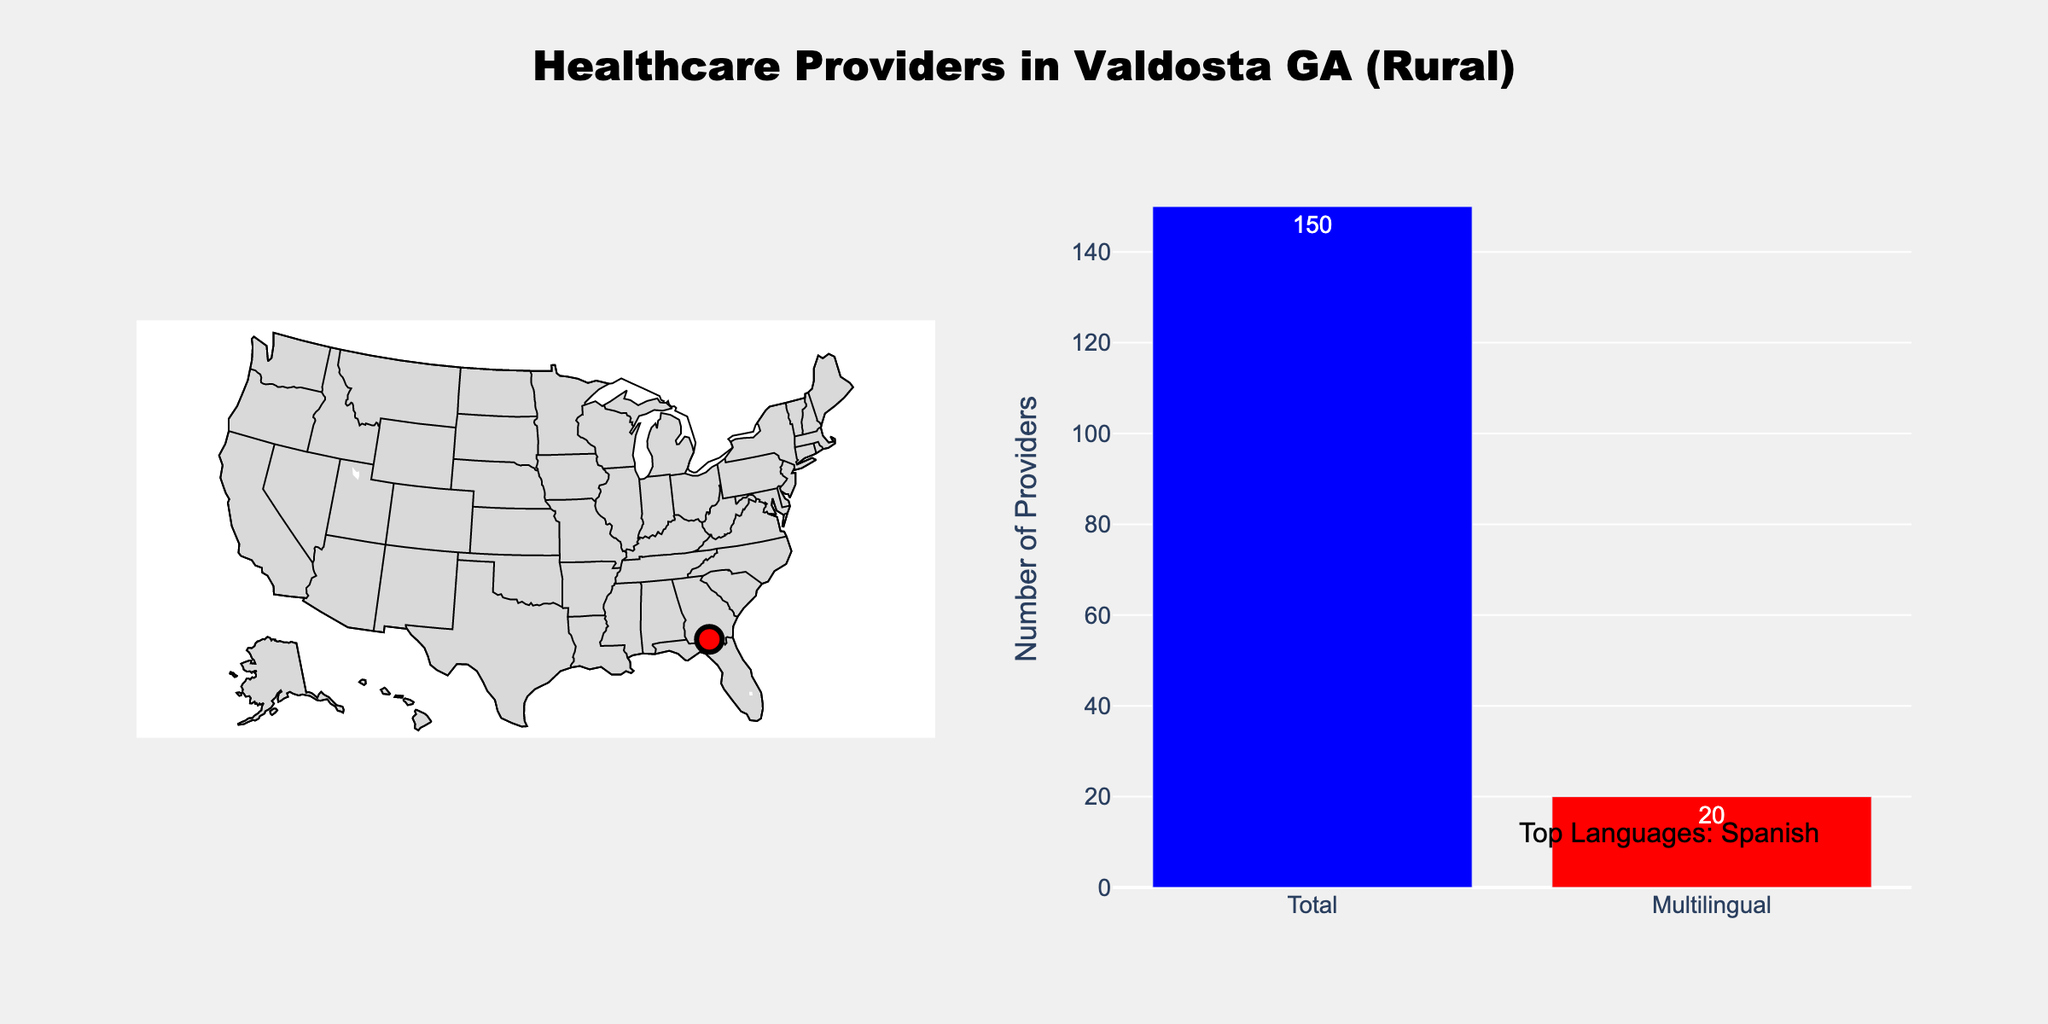What is the title of the figure? The title is displayed at the top center of the figure and reads "Healthcare Providers in Valdosta GA (Rural)".
Answer: Healthcare Providers in Valdosta GA (Rural) How many healthcare providers in Valdosta are multilingual? The bar graph on the right provides a count of multilingual providers, which is marked clearly as 20.
Answer: 20 Which language is predominantly spoken among the multilingual providers in Valdosta? The annotation at the bottom right of the figure specifies the top language as Spanish.
Answer: Spanish What is the difference between the total number of healthcare providers and the number of multilingual providers in Valdosta? From the bar plot, the total number of healthcare providers is 150, and the number of multilingual providers is 20. Subtracting 20 from 150 gives the difference.
Answer: 130 Which color represents multilingual providers in the bar plot? In the bar plot on the right, multilingual providers are represented by the red bar.
Answer: Red Are there more total healthcare providers or multilingual providers in Valdosta? The bar graph on the right shows that the bar for total healthcare providers is significantly taller than the bar for multilingual providers.
Answer: Total healthcare providers How is the geographic location of Valdosta represented on the map? The map uses a red marker to indicate the geographic location of Valdosta, with its longitude and latitude being approximately -83.2785 and 30.8327 respectively.
Answer: Red marker How does the count of multilingual providers compare to the total count? The bar plot compares the two counts, showing that the count of multilingual providers (20) is much lower than the total count (150).
Answer: The count of multilingual providers is lower What is the primary scope of the map displayed in the figure? The map displays the scope as the USA, focusing on land and ocean areas with the southeast region (where Valdosta is located) in view.
Answer: USA What information is provided when hovering over the marker on the map? Hovering over the marker on the map reveals details including the city name (Valdosta), total providers (150), and multilingual providers (20).
Answer: Valdosta, Total Providers: 150, Multilingual Providers: 20 